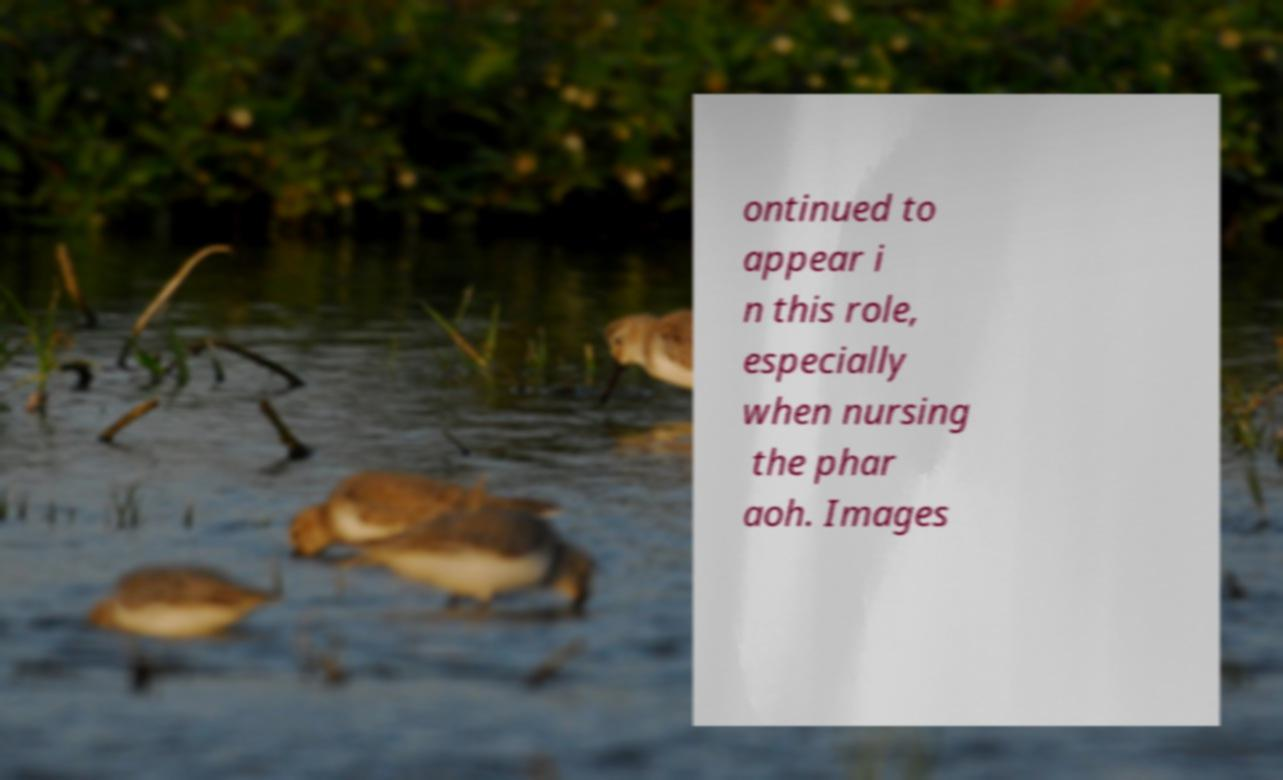There's text embedded in this image that I need extracted. Can you transcribe it verbatim? ontinued to appear i n this role, especially when nursing the phar aoh. Images 